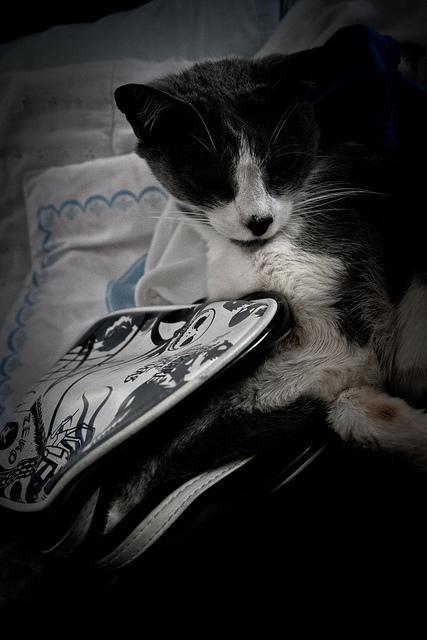How many cats are there?
Give a very brief answer. 1. How many windows on this bus face toward the traffic behind it?
Give a very brief answer. 0. 